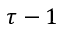Convert formula to latex. <formula><loc_0><loc_0><loc_500><loc_500>\tau - 1</formula> 